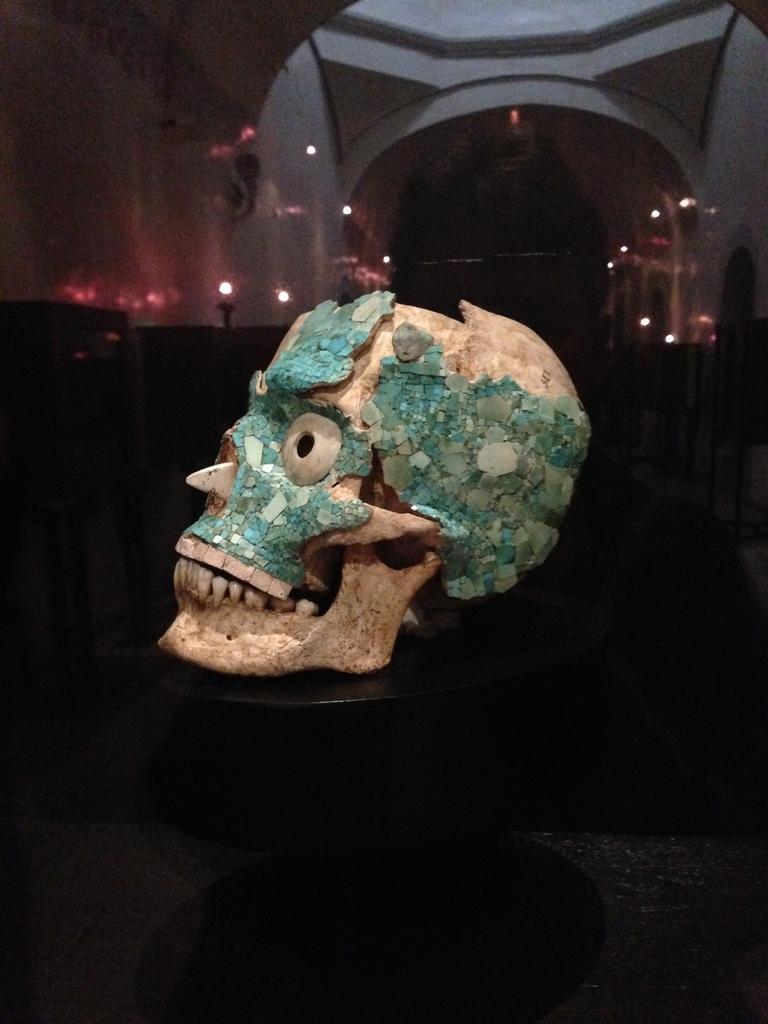How would you summarize this image in a sentence or two? In this image, I can see a skull on the table. In the background, I can see lights, few objects and an arch. 